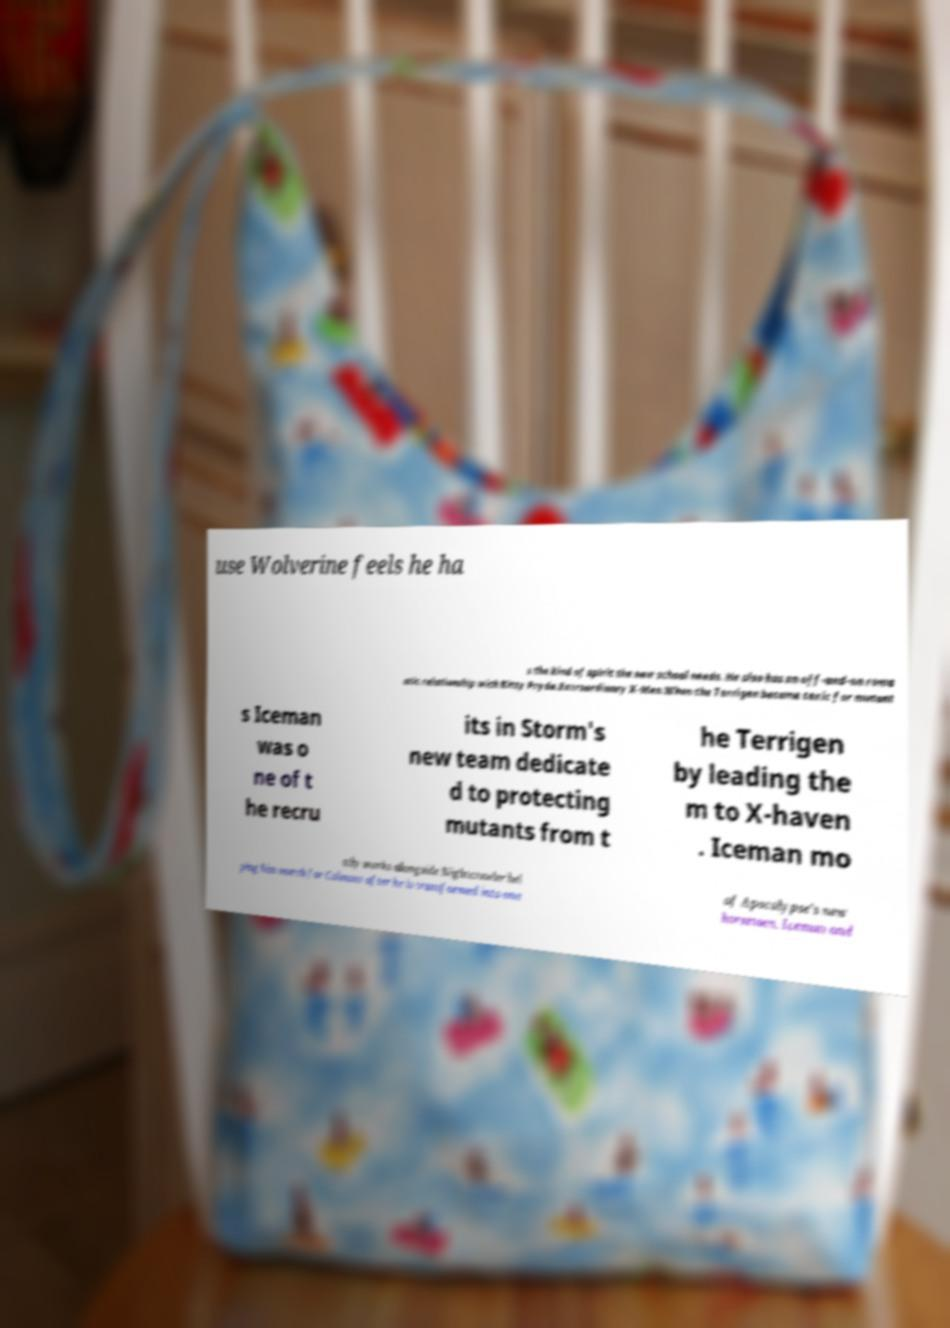Please identify and transcribe the text found in this image. use Wolverine feels he ha s the kind of spirit the new school needs. He also has an off-and-on roma ntic relationship with Kitty Pryde.Extraordinary X-Men.When the Terrigen became toxic for mutant s Iceman was o ne of t he recru its in Storm's new team dedicate d to protecting mutants from t he Terrigen by leading the m to X-haven . Iceman mo stly works alongside Nightcrawler hel ping him search for Colossus after he is transformed into one of Apocalypse's new horsemen. Iceman and 